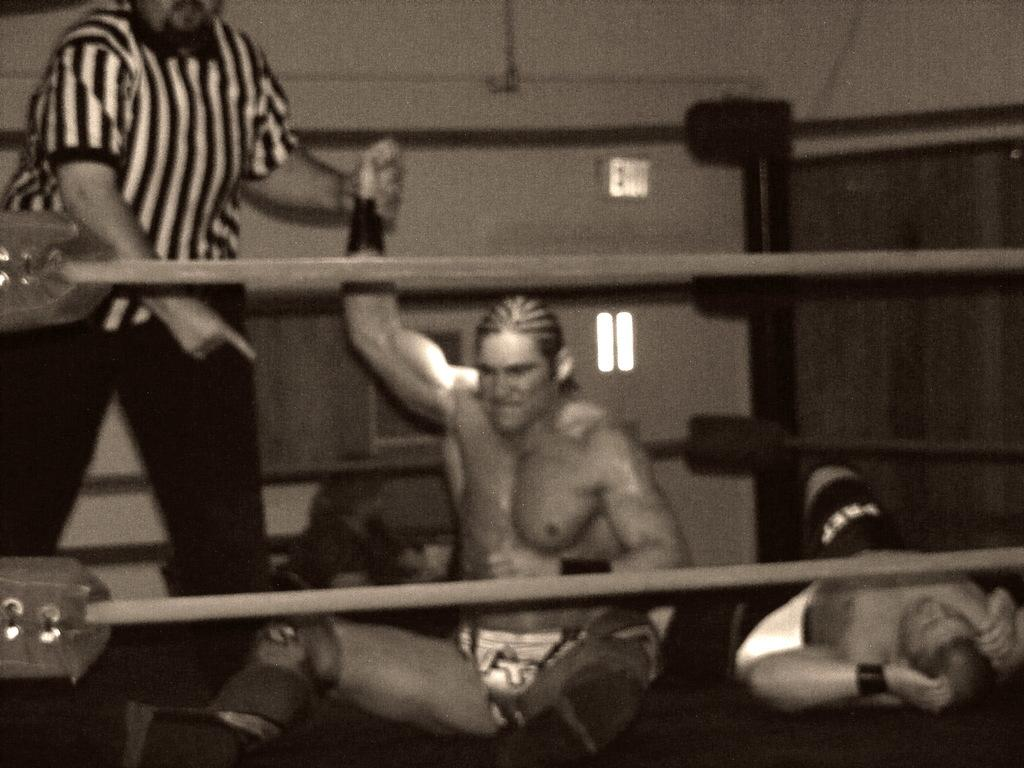What are the people in the image doing? There are persons standing, sitting, and lying in the image. Can you describe the objects in the front of the image? There are tapes in the front of the image. What can be seen in the background of the image? There is a wall and windows in the background of the image. What type of lunchroom can be seen in the image? There is no lunchroom present in the image. Who is the creator of the tapes in the image? The creator of the tapes is not visible or identifiable in the image. 